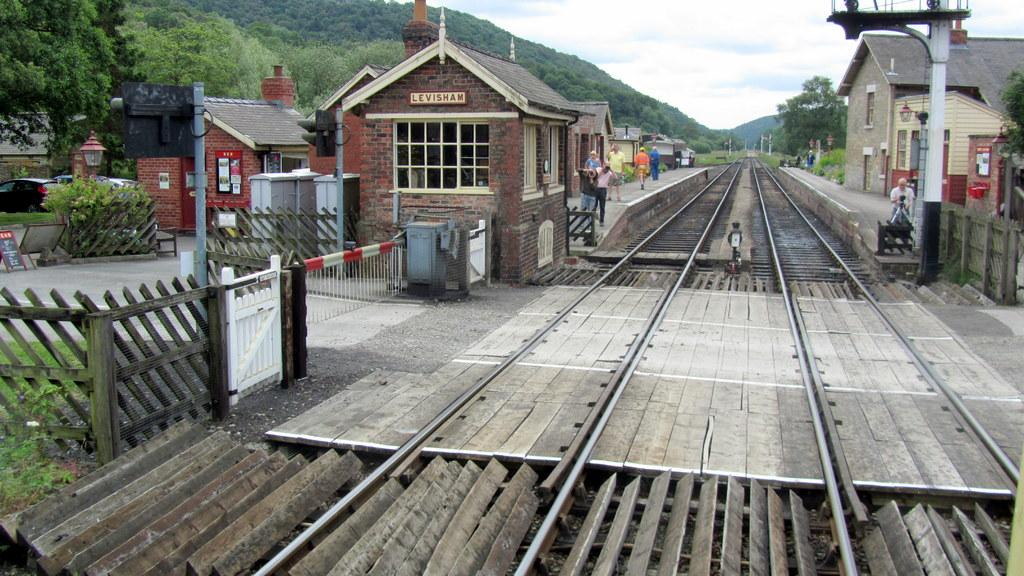What type of structures can be seen in the image? There are houses in the image. What are the people doing in the image? The people are standing on a platform in the image. What type of transportation infrastructure is visible in the image? Railway tracks are visible in the image. What type of barrier is present in the image? There is a fence in the image. What type of vertical structures are present in the image? There are poles in the image. What other objects can be seen on the ground in the image? There are other objects on the ground in the image. What type of natural scenery is visible in the background of the image? Trees are present in the background of the image. What part of the natural environment is visible in the background of the image? The sky is visible in the background of the image. What brand of toothpaste is being advertised on the platform in the image? There is no toothpaste or advertisement present in the image. What committee is responsible for maintaining the railway tracks in the image? There is no committee mentioned or implied in the image. 